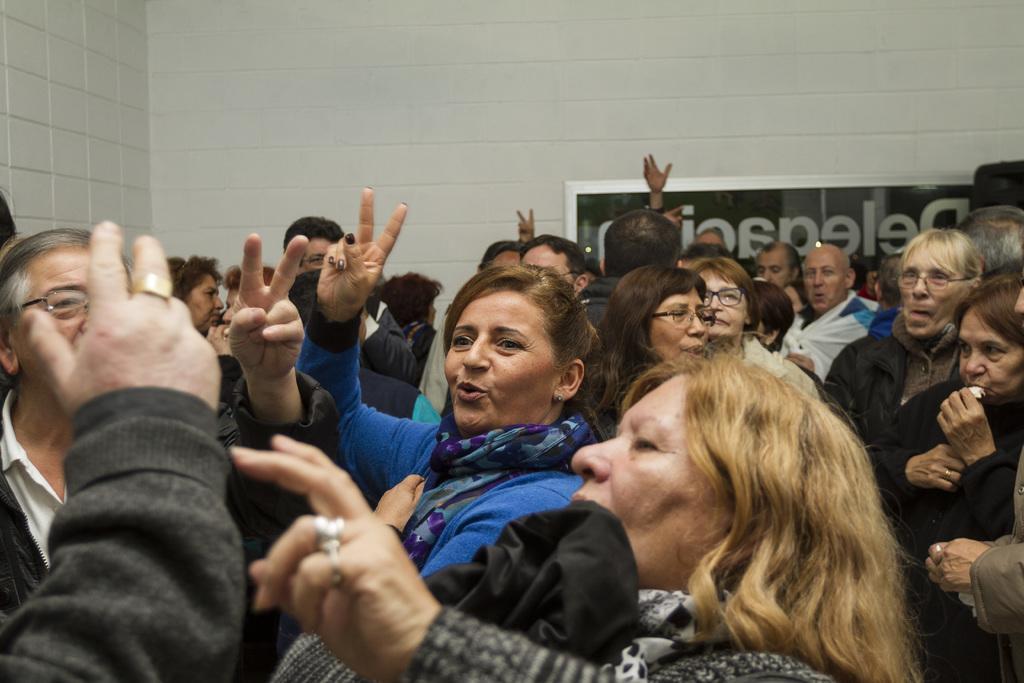How would you summarize this image in a sentence or two? In this image I see number of people in front and in the background I see the white wall and on the wall I see a board on which there is something written. 